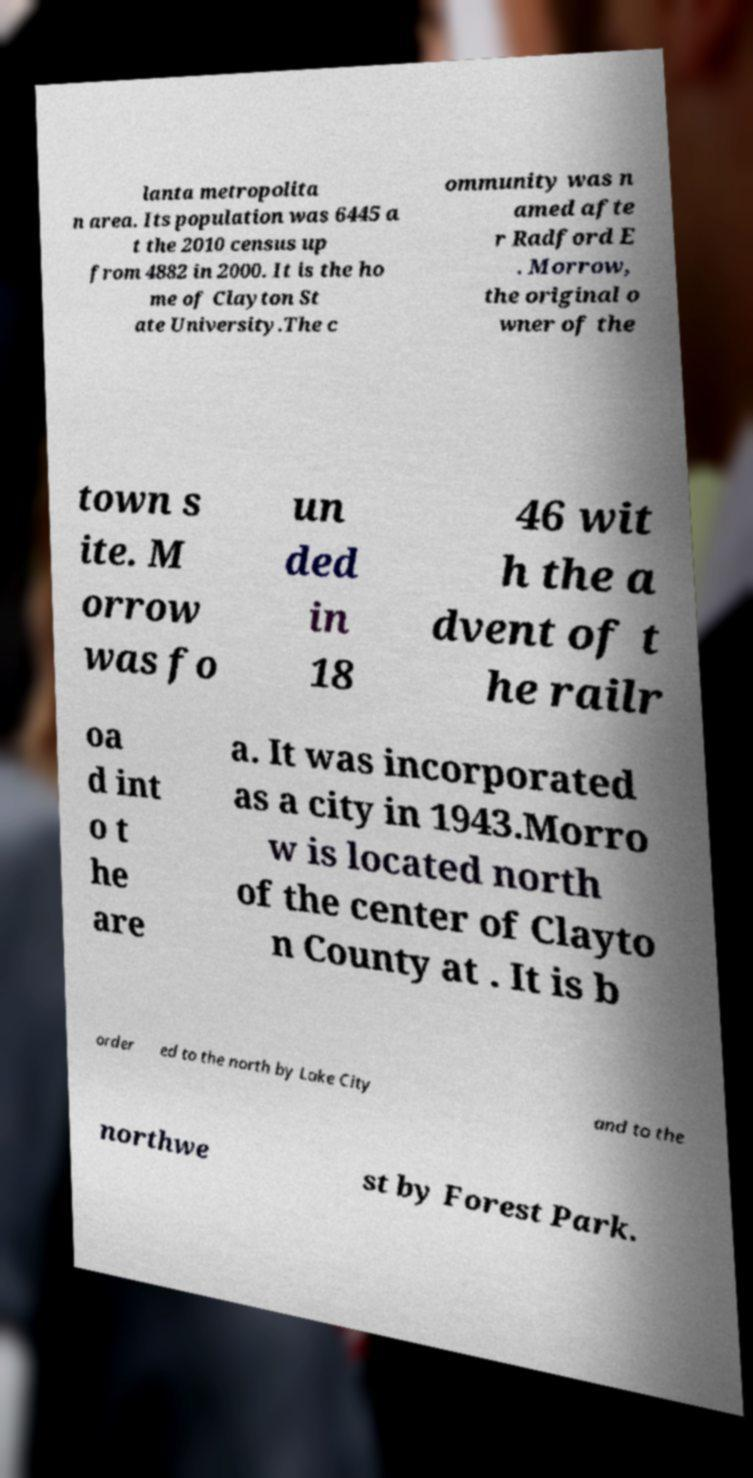Could you extract and type out the text from this image? lanta metropolita n area. Its population was 6445 a t the 2010 census up from 4882 in 2000. It is the ho me of Clayton St ate University.The c ommunity was n amed afte r Radford E . Morrow, the original o wner of the town s ite. M orrow was fo un ded in 18 46 wit h the a dvent of t he railr oa d int o t he are a. It was incorporated as a city in 1943.Morro w is located north of the center of Clayto n County at . It is b order ed to the north by Lake City and to the northwe st by Forest Park. 